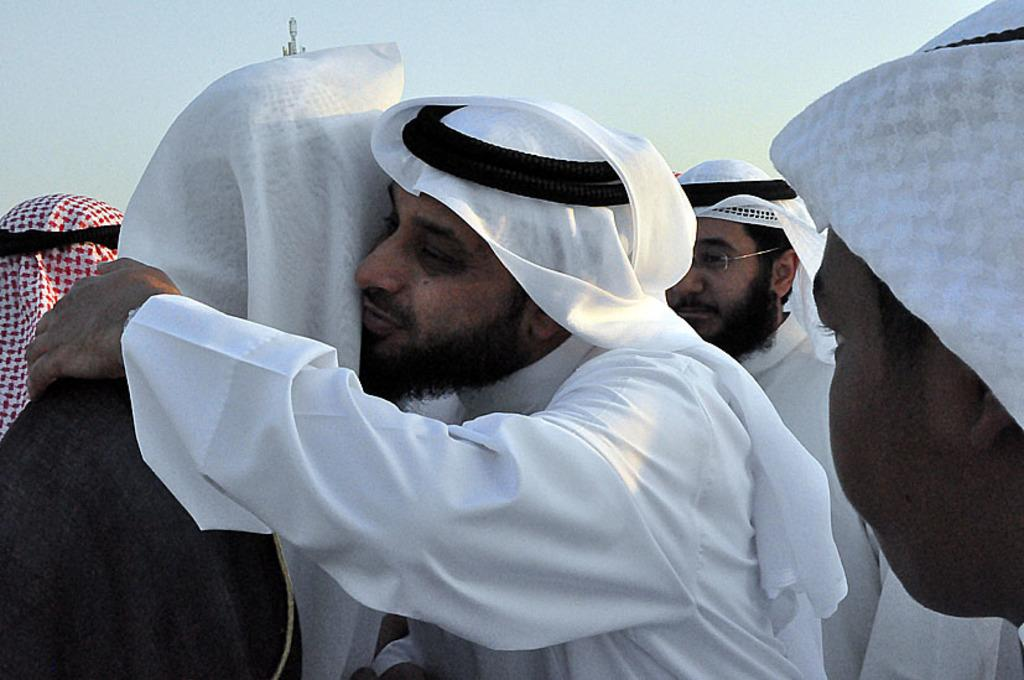What is the main subject of the image? The main subject of the image is a group of people. Can you describe the two persons in the foreground? The two persons in the foreground are hugging. What can be seen in the background of the image? There is a tower in the background of the image. What type of flesh can be seen on the drum in the image? There is no drum or flesh present in the image. How many knives are visible in the image? There are no knives visible in the image. 